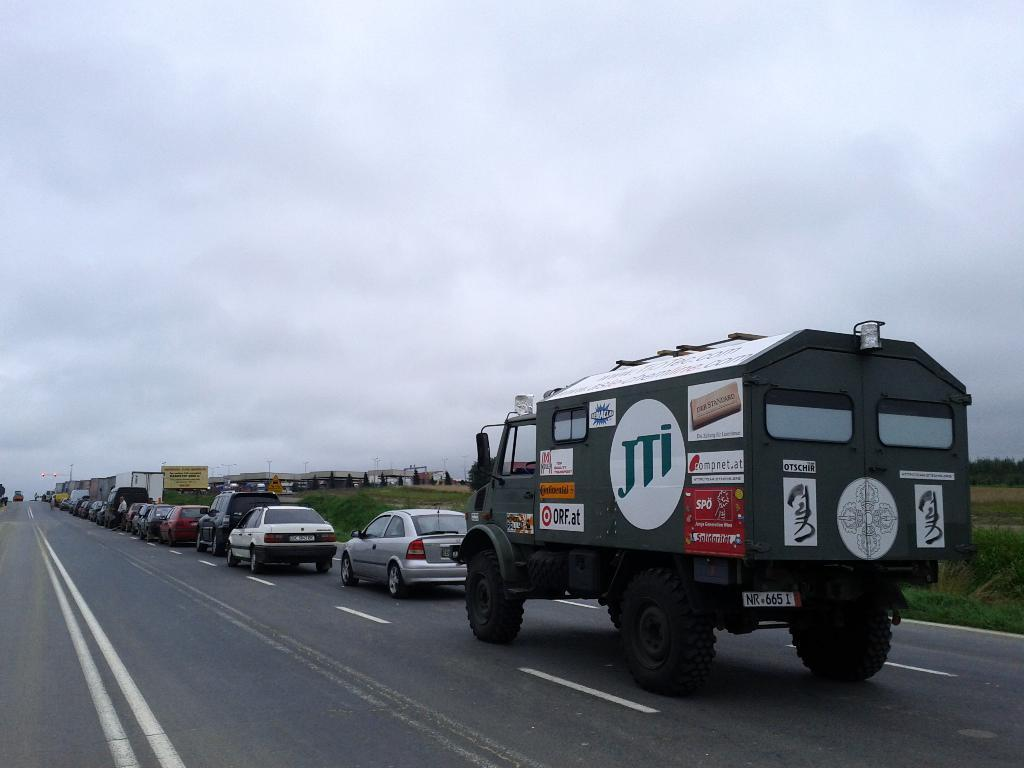What can be seen on the road in the image? There are vehicles on the road in the image. What is visible in the background of the image? The sky, trees, grass, boards, and street lights are visible in the background of the image. Can you describe the natural elements present in the background? Trees and grass are the natural elements present in the background of the image. What type of man-made objects can be seen in the background? Boards and street lights are the man-made objects visible in the background of the image. What is the value of the church in the image? There is no church present in the image, so it is not possible to determine its value. 